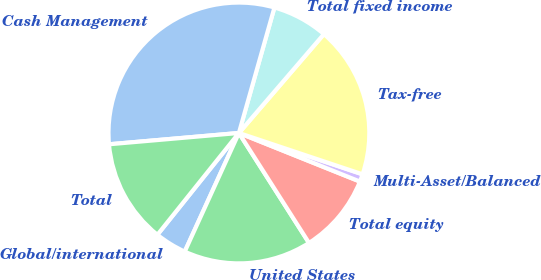Convert chart. <chart><loc_0><loc_0><loc_500><loc_500><pie_chart><fcel>Global/international<fcel>United States<fcel>Total equity<fcel>Multi-Asset/Balanced<fcel>Tax-free<fcel>Total fixed income<fcel>Cash Management<fcel>Total<nl><fcel>3.93%<fcel>15.85%<fcel>9.89%<fcel>0.94%<fcel>18.83%<fcel>6.91%<fcel>30.77%<fcel>12.87%<nl></chart> 